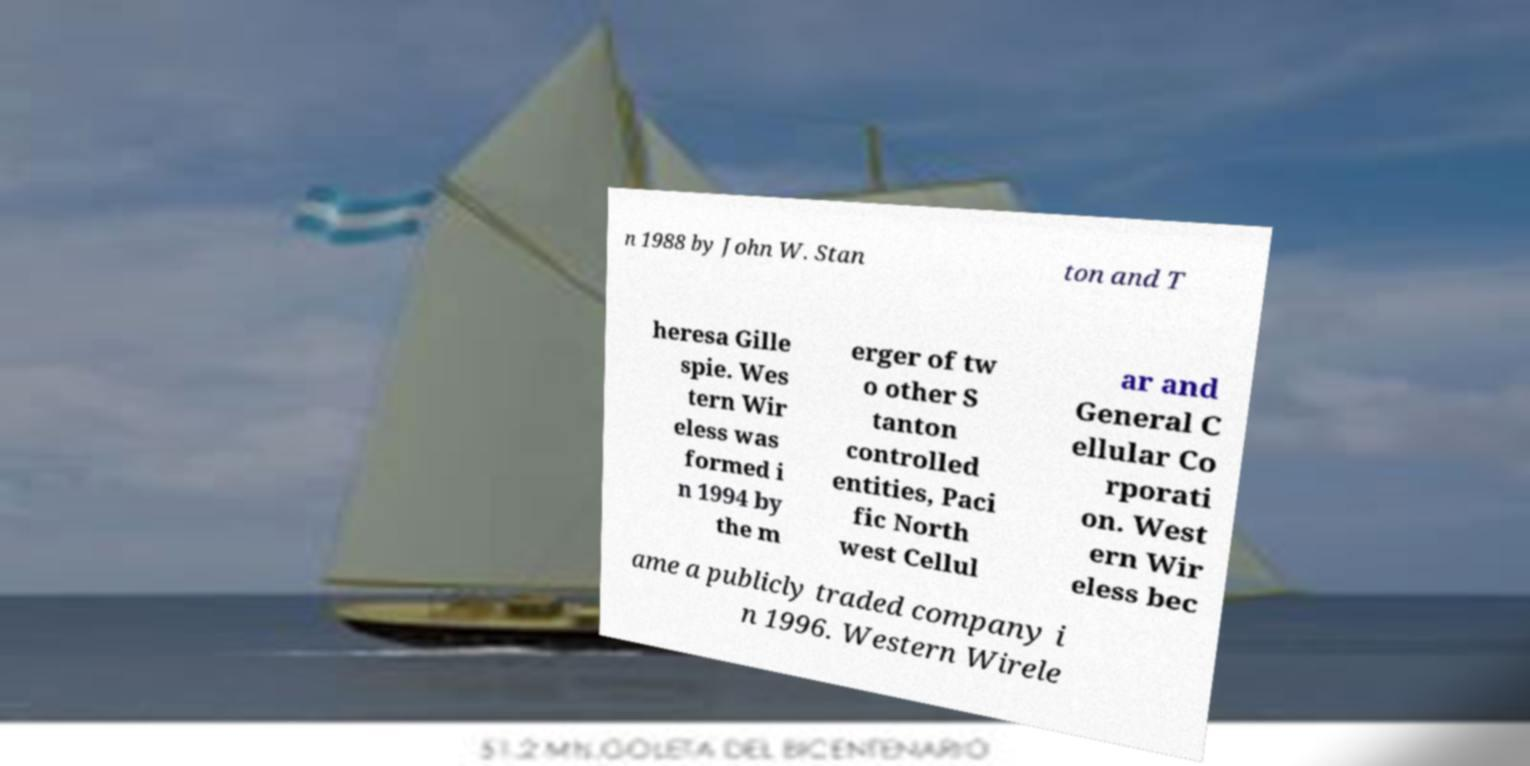For documentation purposes, I need the text within this image transcribed. Could you provide that? n 1988 by John W. Stan ton and T heresa Gille spie. Wes tern Wir eless was formed i n 1994 by the m erger of tw o other S tanton controlled entities, Paci fic North west Cellul ar and General C ellular Co rporati on. West ern Wir eless bec ame a publicly traded company i n 1996. Western Wirele 